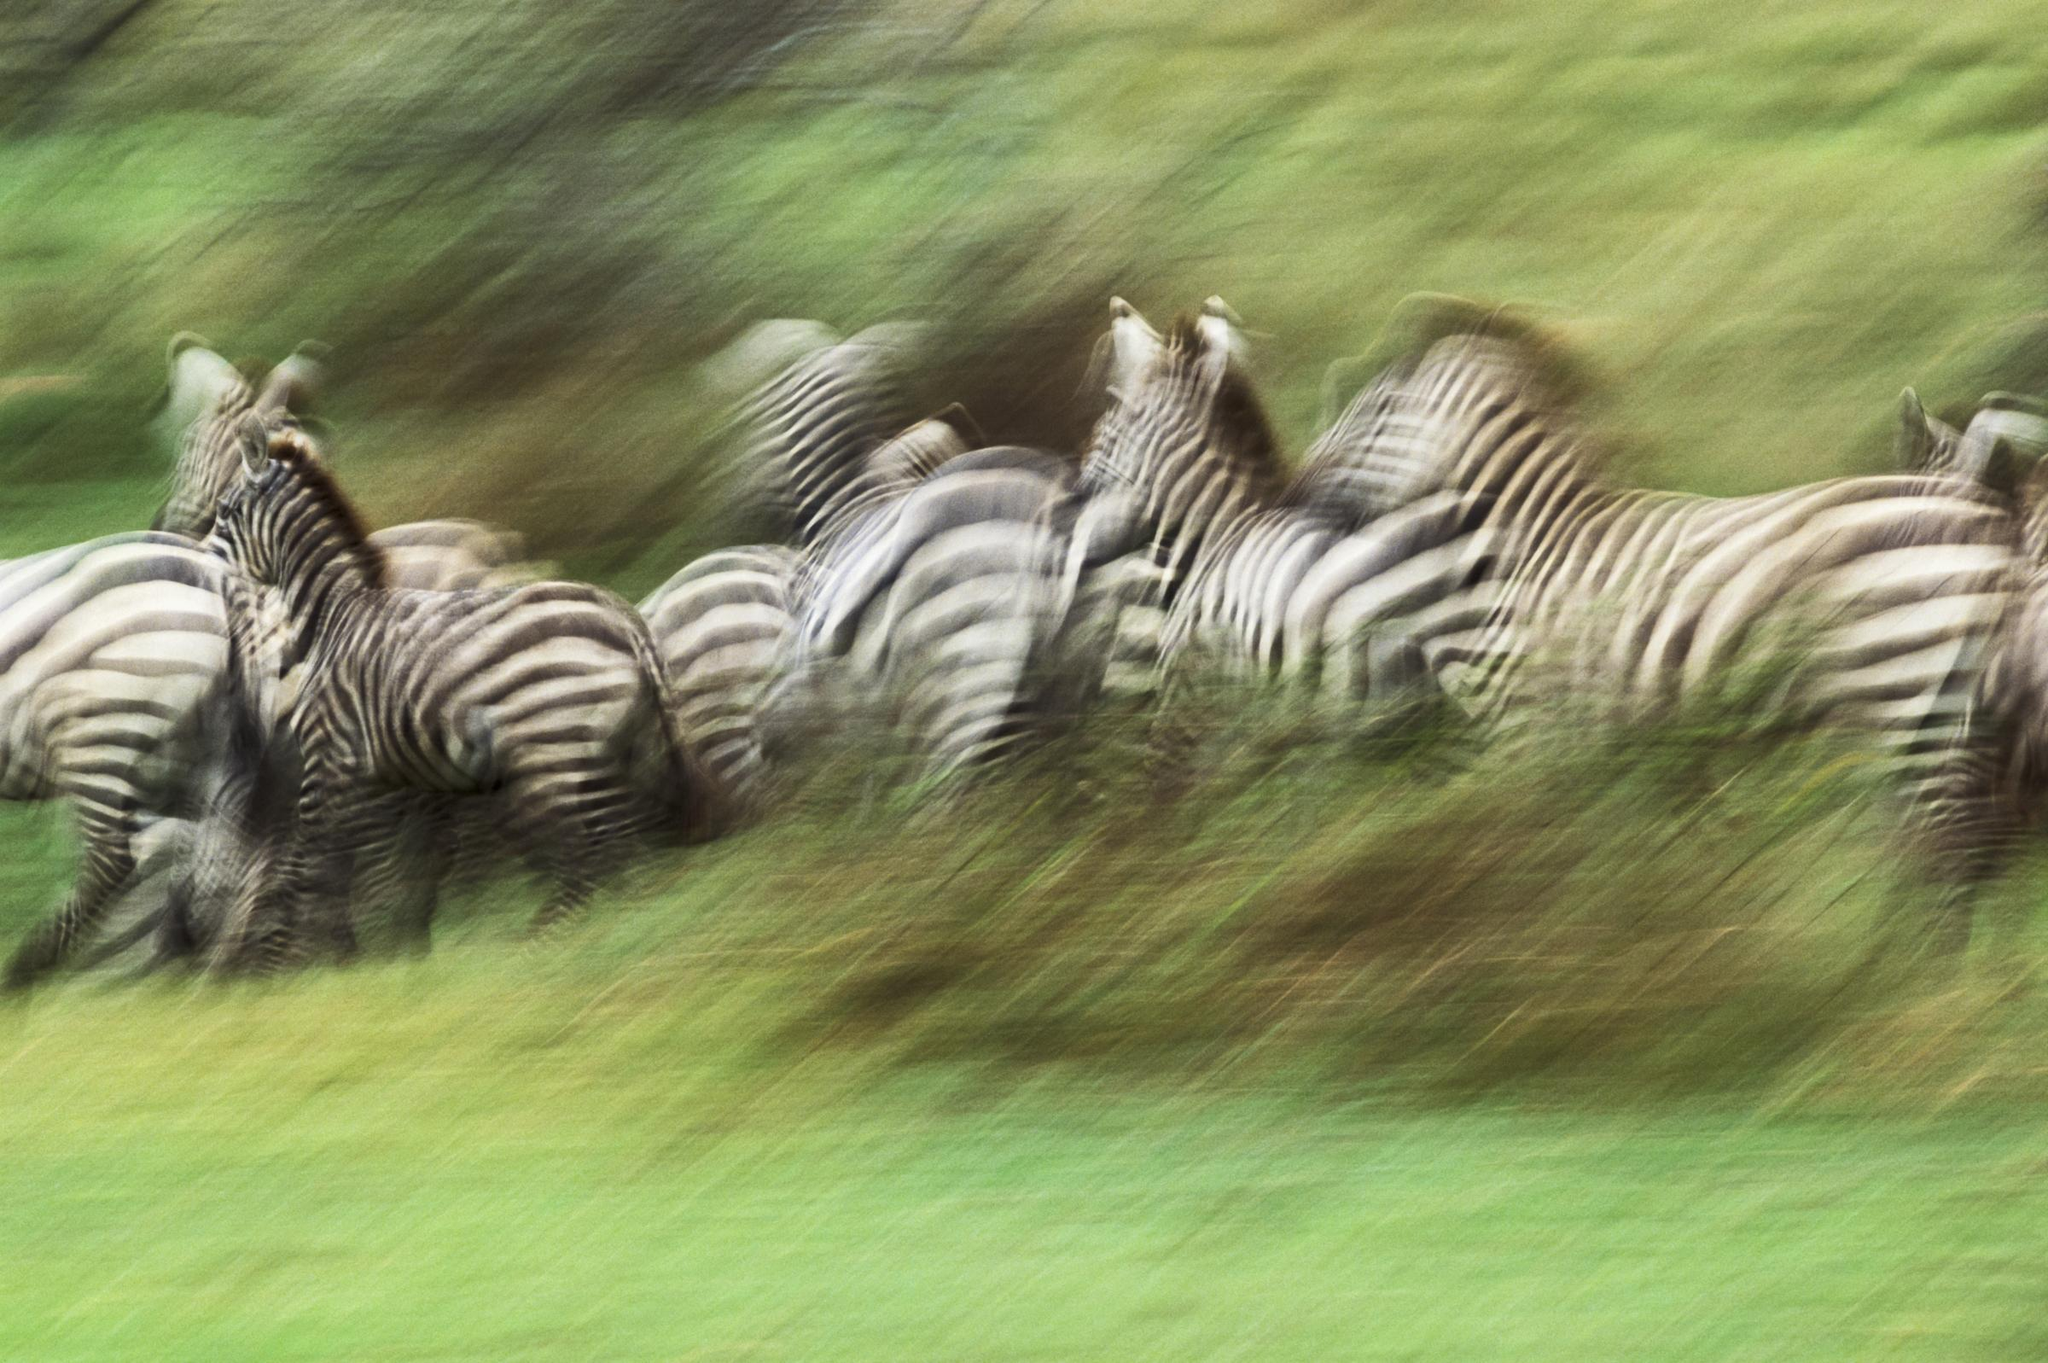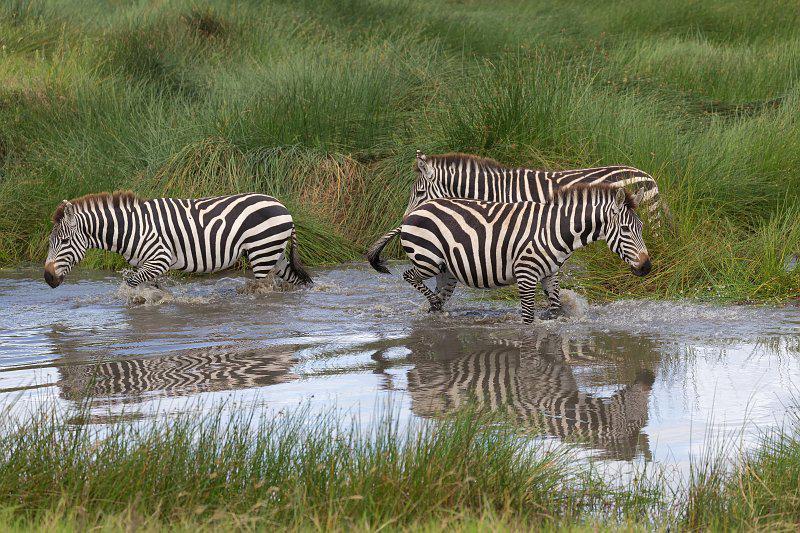The first image is the image on the left, the second image is the image on the right. Analyze the images presented: Is the assertion "The image on the right has two or fewer zebras." valid? Answer yes or no. No. 